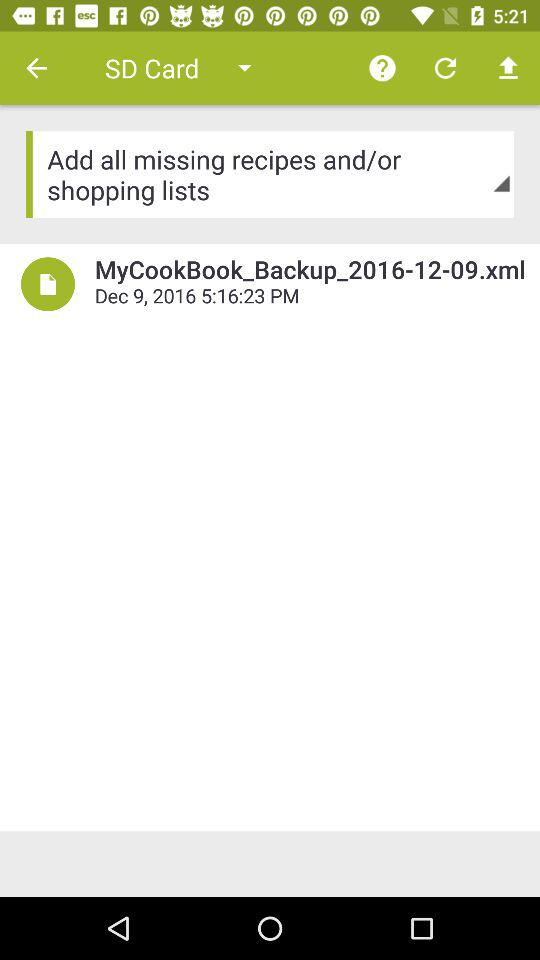What is the date and time of the backup? The date and time of the backup are December 9, 2016 and 5:16:23 PM. 